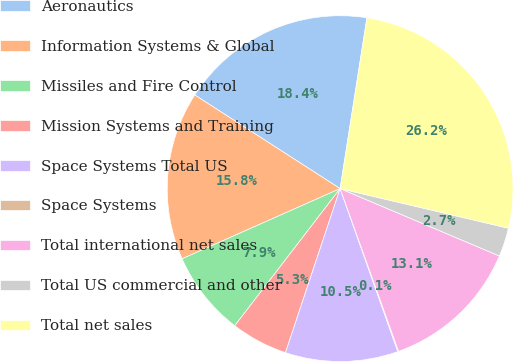<chart> <loc_0><loc_0><loc_500><loc_500><pie_chart><fcel>Aeronautics<fcel>Information Systems & Global<fcel>Missiles and Fire Control<fcel>Mission Systems and Training<fcel>Space Systems Total US<fcel>Space Systems<fcel>Total international net sales<fcel>Total US commercial and other<fcel>Total net sales<nl><fcel>18.37%<fcel>15.76%<fcel>7.92%<fcel>5.31%<fcel>10.53%<fcel>0.08%<fcel>13.14%<fcel>2.69%<fcel>26.2%<nl></chart> 